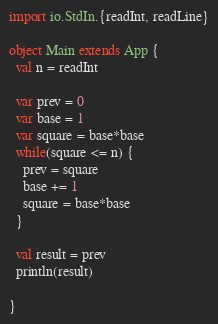<code> <loc_0><loc_0><loc_500><loc_500><_Scala_>import io.StdIn.{readInt, readLine}

object Main extends App {
  val n = readInt

  var prev = 0
  var base = 1
  var square = base*base
  while(square <= n) {
    prev = square
    base += 1
    square = base*base
  }

  val result = prev
  println(result)

}</code> 